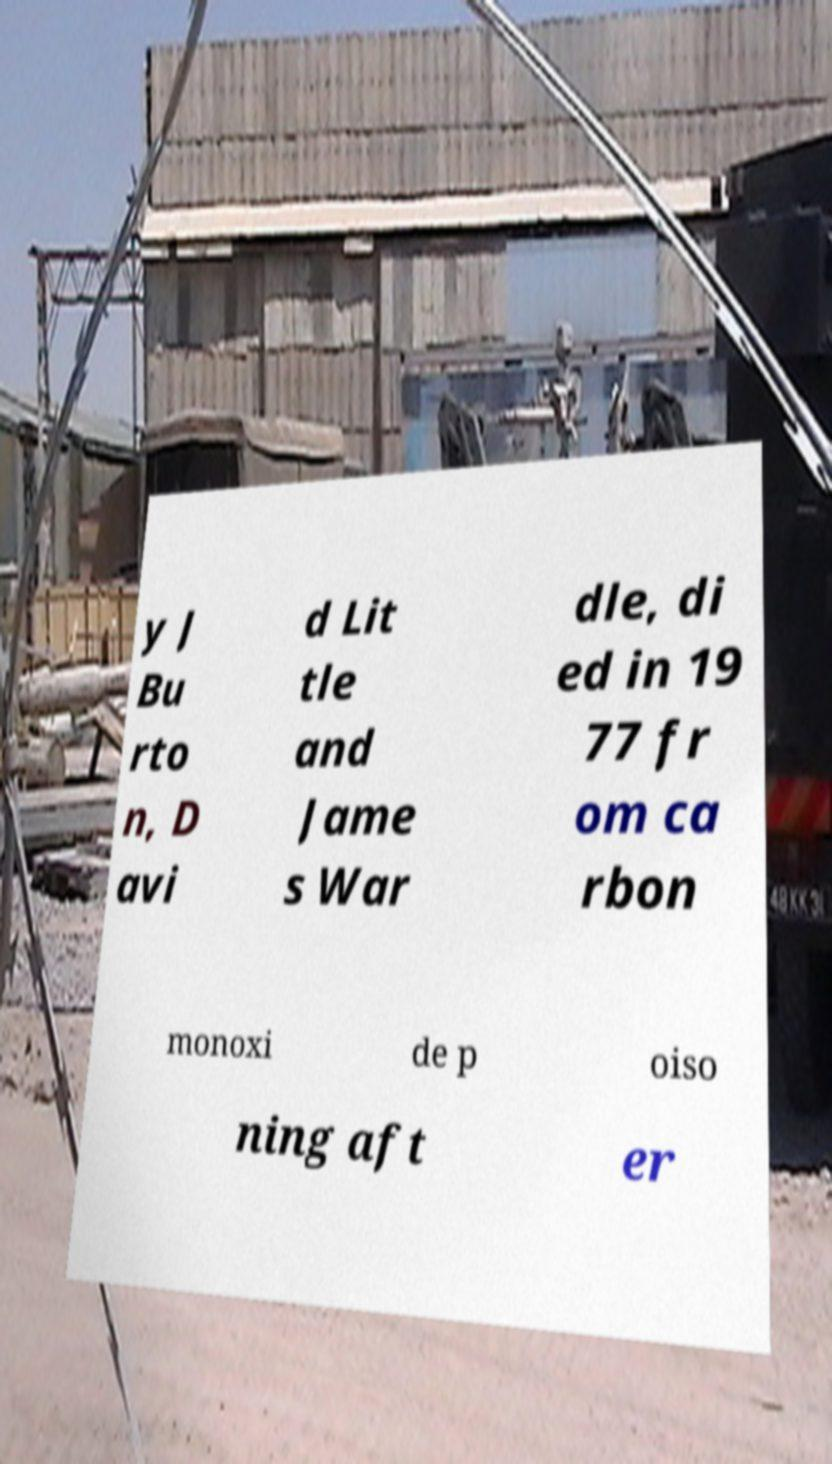Please identify and transcribe the text found in this image. y J Bu rto n, D avi d Lit tle and Jame s War dle, di ed in 19 77 fr om ca rbon monoxi de p oiso ning aft er 